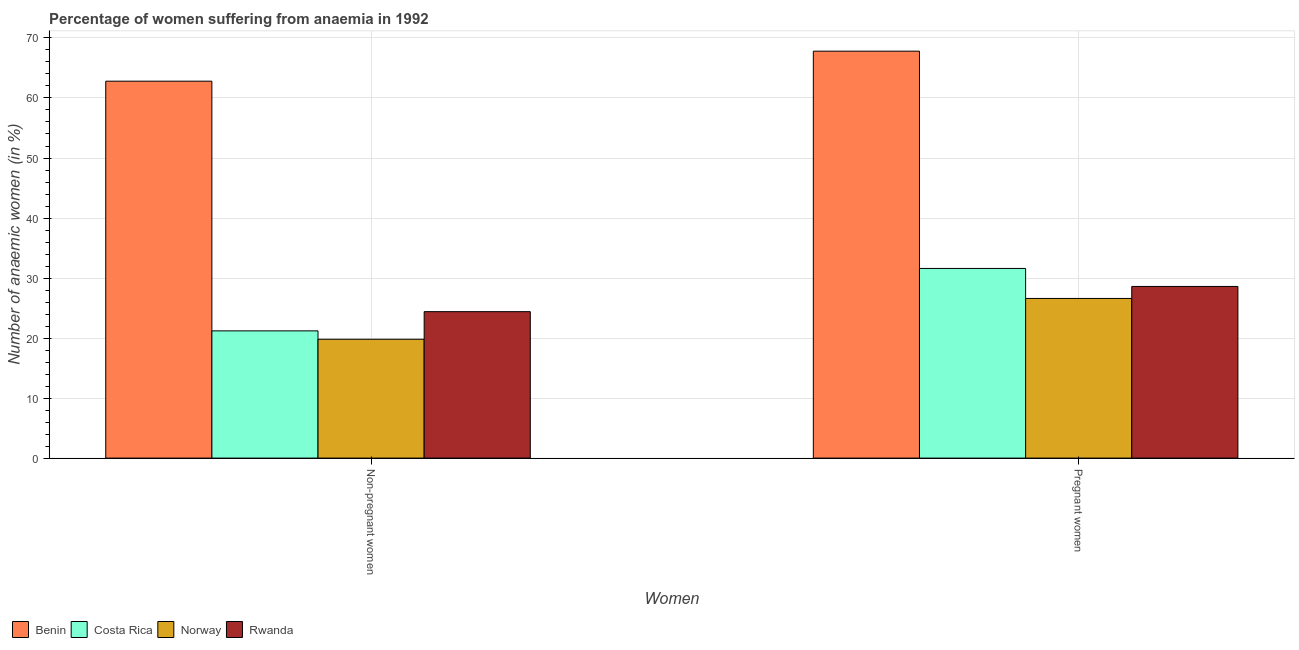How many different coloured bars are there?
Offer a terse response. 4. How many groups of bars are there?
Keep it short and to the point. 2. Are the number of bars on each tick of the X-axis equal?
Provide a succinct answer. Yes. How many bars are there on the 1st tick from the left?
Provide a succinct answer. 4. How many bars are there on the 1st tick from the right?
Provide a succinct answer. 4. What is the label of the 2nd group of bars from the left?
Ensure brevity in your answer.  Pregnant women. What is the percentage of pregnant anaemic women in Norway?
Your answer should be very brief. 26.6. Across all countries, what is the maximum percentage of pregnant anaemic women?
Offer a very short reply. 67.8. Across all countries, what is the minimum percentage of non-pregnant anaemic women?
Your response must be concise. 19.8. In which country was the percentage of pregnant anaemic women maximum?
Provide a succinct answer. Benin. In which country was the percentage of non-pregnant anaemic women minimum?
Offer a terse response. Norway. What is the total percentage of non-pregnant anaemic women in the graph?
Your answer should be compact. 128.2. What is the difference between the percentage of pregnant anaemic women in Rwanda and that in Benin?
Your response must be concise. -39.2. What is the difference between the percentage of non-pregnant anaemic women in Costa Rica and the percentage of pregnant anaemic women in Benin?
Make the answer very short. -46.6. What is the average percentage of pregnant anaemic women per country?
Offer a very short reply. 38.65. What is the difference between the percentage of non-pregnant anaemic women and percentage of pregnant anaemic women in Benin?
Make the answer very short. -5. In how many countries, is the percentage of non-pregnant anaemic women greater than 22 %?
Your response must be concise. 2. What is the ratio of the percentage of pregnant anaemic women in Costa Rica to that in Norway?
Offer a terse response. 1.19. What does the 4th bar from the right in Pregnant women represents?
Your response must be concise. Benin. How many bars are there?
Your answer should be compact. 8. Are the values on the major ticks of Y-axis written in scientific E-notation?
Ensure brevity in your answer.  No. Does the graph contain any zero values?
Your answer should be very brief. No. How many legend labels are there?
Provide a short and direct response. 4. How are the legend labels stacked?
Your answer should be compact. Horizontal. What is the title of the graph?
Keep it short and to the point. Percentage of women suffering from anaemia in 1992. What is the label or title of the X-axis?
Make the answer very short. Women. What is the label or title of the Y-axis?
Provide a short and direct response. Number of anaemic women (in %). What is the Number of anaemic women (in %) in Benin in Non-pregnant women?
Offer a very short reply. 62.8. What is the Number of anaemic women (in %) in Costa Rica in Non-pregnant women?
Offer a very short reply. 21.2. What is the Number of anaemic women (in %) in Norway in Non-pregnant women?
Ensure brevity in your answer.  19.8. What is the Number of anaemic women (in %) in Rwanda in Non-pregnant women?
Your answer should be compact. 24.4. What is the Number of anaemic women (in %) in Benin in Pregnant women?
Your response must be concise. 67.8. What is the Number of anaemic women (in %) of Costa Rica in Pregnant women?
Offer a very short reply. 31.6. What is the Number of anaemic women (in %) of Norway in Pregnant women?
Make the answer very short. 26.6. What is the Number of anaemic women (in %) in Rwanda in Pregnant women?
Your answer should be compact. 28.6. Across all Women, what is the maximum Number of anaemic women (in %) in Benin?
Keep it short and to the point. 67.8. Across all Women, what is the maximum Number of anaemic women (in %) in Costa Rica?
Keep it short and to the point. 31.6. Across all Women, what is the maximum Number of anaemic women (in %) in Norway?
Provide a succinct answer. 26.6. Across all Women, what is the maximum Number of anaemic women (in %) of Rwanda?
Your answer should be compact. 28.6. Across all Women, what is the minimum Number of anaemic women (in %) of Benin?
Offer a very short reply. 62.8. Across all Women, what is the minimum Number of anaemic women (in %) of Costa Rica?
Your answer should be very brief. 21.2. Across all Women, what is the minimum Number of anaemic women (in %) in Norway?
Offer a terse response. 19.8. Across all Women, what is the minimum Number of anaemic women (in %) in Rwanda?
Your answer should be very brief. 24.4. What is the total Number of anaemic women (in %) in Benin in the graph?
Provide a succinct answer. 130.6. What is the total Number of anaemic women (in %) in Costa Rica in the graph?
Your answer should be compact. 52.8. What is the total Number of anaemic women (in %) of Norway in the graph?
Make the answer very short. 46.4. What is the total Number of anaemic women (in %) in Rwanda in the graph?
Give a very brief answer. 53. What is the difference between the Number of anaemic women (in %) of Norway in Non-pregnant women and that in Pregnant women?
Give a very brief answer. -6.8. What is the difference between the Number of anaemic women (in %) in Benin in Non-pregnant women and the Number of anaemic women (in %) in Costa Rica in Pregnant women?
Provide a succinct answer. 31.2. What is the difference between the Number of anaemic women (in %) in Benin in Non-pregnant women and the Number of anaemic women (in %) in Norway in Pregnant women?
Provide a short and direct response. 36.2. What is the difference between the Number of anaemic women (in %) of Benin in Non-pregnant women and the Number of anaemic women (in %) of Rwanda in Pregnant women?
Provide a short and direct response. 34.2. What is the average Number of anaemic women (in %) in Benin per Women?
Provide a short and direct response. 65.3. What is the average Number of anaemic women (in %) in Costa Rica per Women?
Provide a short and direct response. 26.4. What is the average Number of anaemic women (in %) in Norway per Women?
Provide a succinct answer. 23.2. What is the average Number of anaemic women (in %) in Rwanda per Women?
Ensure brevity in your answer.  26.5. What is the difference between the Number of anaemic women (in %) of Benin and Number of anaemic women (in %) of Costa Rica in Non-pregnant women?
Your answer should be very brief. 41.6. What is the difference between the Number of anaemic women (in %) of Benin and Number of anaemic women (in %) of Rwanda in Non-pregnant women?
Your answer should be very brief. 38.4. What is the difference between the Number of anaemic women (in %) of Costa Rica and Number of anaemic women (in %) of Norway in Non-pregnant women?
Your answer should be compact. 1.4. What is the difference between the Number of anaemic women (in %) in Costa Rica and Number of anaemic women (in %) in Rwanda in Non-pregnant women?
Your answer should be compact. -3.2. What is the difference between the Number of anaemic women (in %) of Benin and Number of anaemic women (in %) of Costa Rica in Pregnant women?
Your response must be concise. 36.2. What is the difference between the Number of anaemic women (in %) in Benin and Number of anaemic women (in %) in Norway in Pregnant women?
Provide a short and direct response. 41.2. What is the difference between the Number of anaemic women (in %) of Benin and Number of anaemic women (in %) of Rwanda in Pregnant women?
Your answer should be very brief. 39.2. What is the difference between the Number of anaemic women (in %) of Costa Rica and Number of anaemic women (in %) of Norway in Pregnant women?
Offer a terse response. 5. What is the difference between the Number of anaemic women (in %) of Norway and Number of anaemic women (in %) of Rwanda in Pregnant women?
Provide a short and direct response. -2. What is the ratio of the Number of anaemic women (in %) of Benin in Non-pregnant women to that in Pregnant women?
Make the answer very short. 0.93. What is the ratio of the Number of anaemic women (in %) of Costa Rica in Non-pregnant women to that in Pregnant women?
Offer a terse response. 0.67. What is the ratio of the Number of anaemic women (in %) of Norway in Non-pregnant women to that in Pregnant women?
Keep it short and to the point. 0.74. What is the ratio of the Number of anaemic women (in %) in Rwanda in Non-pregnant women to that in Pregnant women?
Keep it short and to the point. 0.85. What is the difference between the highest and the second highest Number of anaemic women (in %) in Costa Rica?
Your answer should be compact. 10.4. What is the difference between the highest and the second highest Number of anaemic women (in %) in Rwanda?
Offer a terse response. 4.2. What is the difference between the highest and the lowest Number of anaemic women (in %) in Costa Rica?
Offer a very short reply. 10.4. What is the difference between the highest and the lowest Number of anaemic women (in %) of Norway?
Your answer should be compact. 6.8. What is the difference between the highest and the lowest Number of anaemic women (in %) in Rwanda?
Your response must be concise. 4.2. 